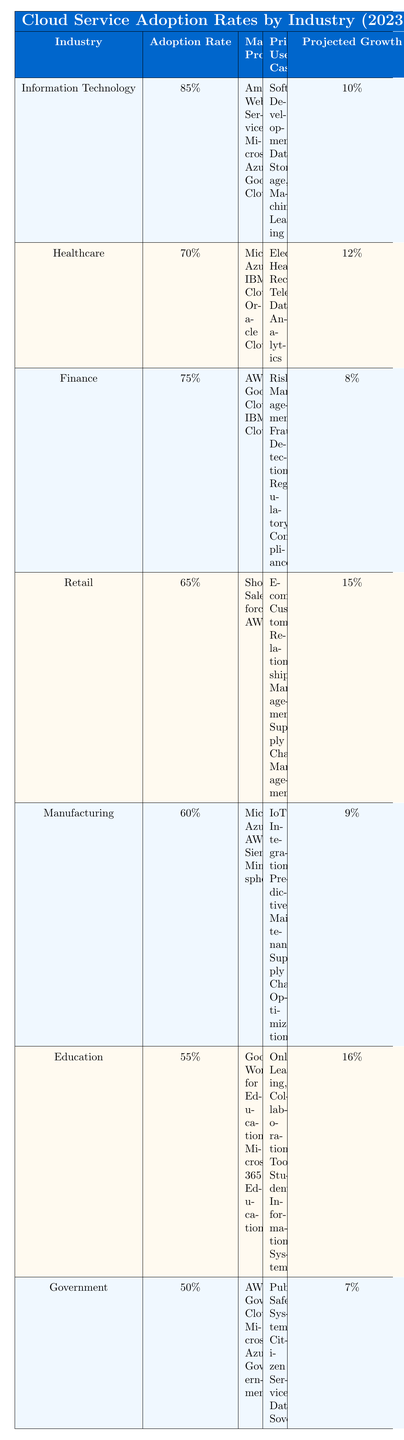What is the adoption rate for the Healthcare industry? The Healthcare industry has an adoption rate listed in the table of 70%.
Answer: 70% Which industry has the highest adoption rate? Referring to the table, the Information Technology industry has the highest adoption rate at 85%.
Answer: Information Technology What are the primary use cases for the Retail industry? Looking at the table, the primary use cases for Retail are E-commerce, Customer Relationship Management, and Supply Chain Management.
Answer: E-commerce, Customer Relationship Management, Supply Chain Management What is the projected growth rate for Education? The projected growth rate for Education is found in the table, where it is listed as 16%.
Answer: 16% Is the adoption rate for Government higher than that of Manufacturing? In the table, the Government industry has an adoption rate of 50%, while Manufacturing has a rate of 60%. Since 50% is not higher than 60%, the answer is no.
Answer: No What is the average adoption rate of all industries listed? To find the average, sum the adoption rates: (85 + 70 + 75 + 65 + 60 + 55 + 50) = 490. Then, divide by the number of industries (7): 490/7 = 70.
Answer: 70 Which major provider is associated with both Information Technology and Manufacturing sectors? The table lists Microsoft Azure as a major provider for both the Information Technology and Manufacturing industries, confirming the association.
Answer: Microsoft Azure What is the difference in projected growth between the Retail and Government industries? In the table, the projected growth for Retail is 15% and for Government is 7%. The difference is calculated as 15 - 7 = 8.
Answer: 8 How many industries have an adoption rate of 65% or lower? Referring to the table, there are three industries (Retail at 65%, Manufacturing at 60%, Education at 55%, Government at 50%) that have adoption rates of 65% or lower, making a total of four.
Answer: 4 Are electronic health records a primary use case for the Finance industry? The table indicates that the primary use cases for the Finance industry are Risk Management, Fraud Detection, and Regulatory Compliance. Since electronic health records are not listed, the answer is no.
Answer: No 